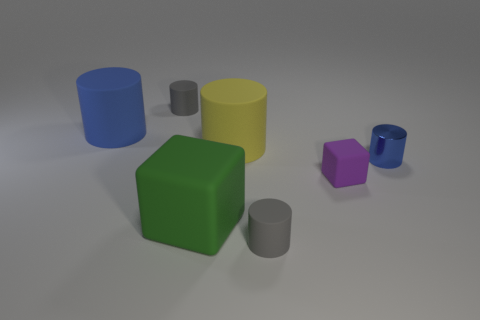Subtract all brown spheres. How many gray cylinders are left? 2 Subtract all yellow cylinders. How many cylinders are left? 4 Add 2 big matte cylinders. How many objects exist? 9 Subtract 2 cylinders. How many cylinders are left? 3 Subtract all gray cylinders. How many cylinders are left? 3 Subtract all blocks. How many objects are left? 5 Subtract all yellow cubes. Subtract all cyan spheres. How many cubes are left? 2 Subtract all big yellow cylinders. Subtract all tiny rubber blocks. How many objects are left? 5 Add 7 big yellow matte cylinders. How many big yellow matte cylinders are left? 8 Add 1 big yellow rubber things. How many big yellow rubber things exist? 2 